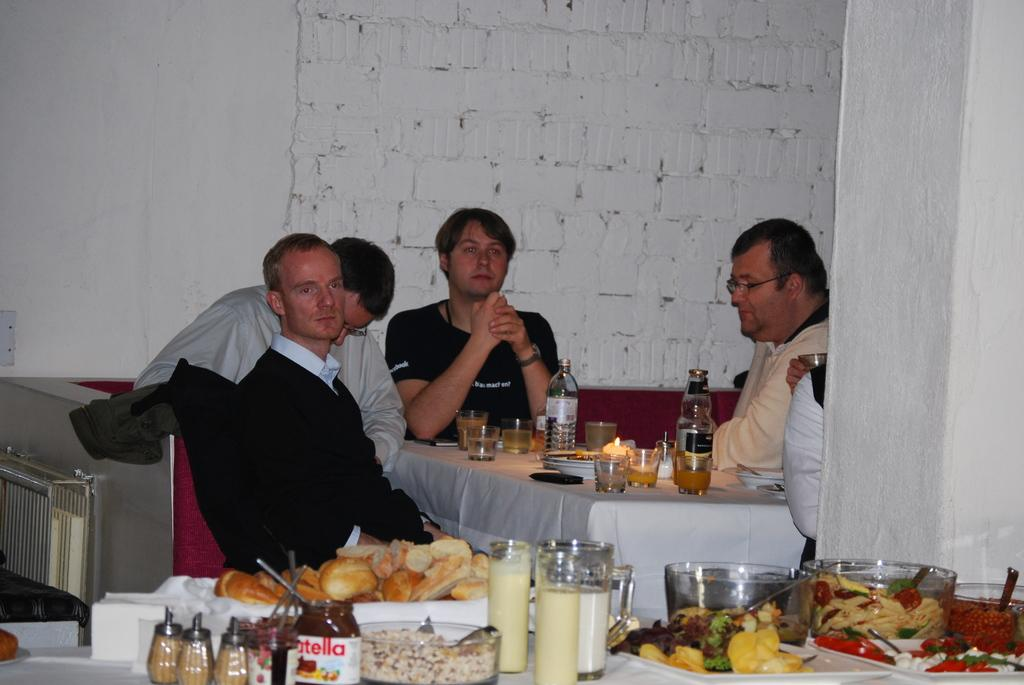<image>
Offer a succinct explanation of the picture presented. Group of diners gathered around the table with an offering of Nutella and bread on display. 